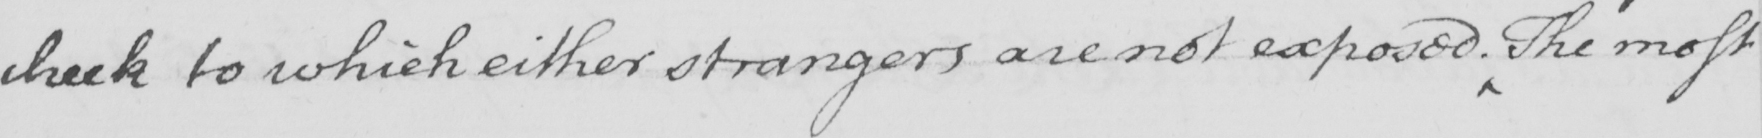Please provide the text content of this handwritten line. check to which either strangers are not exposed . The most 